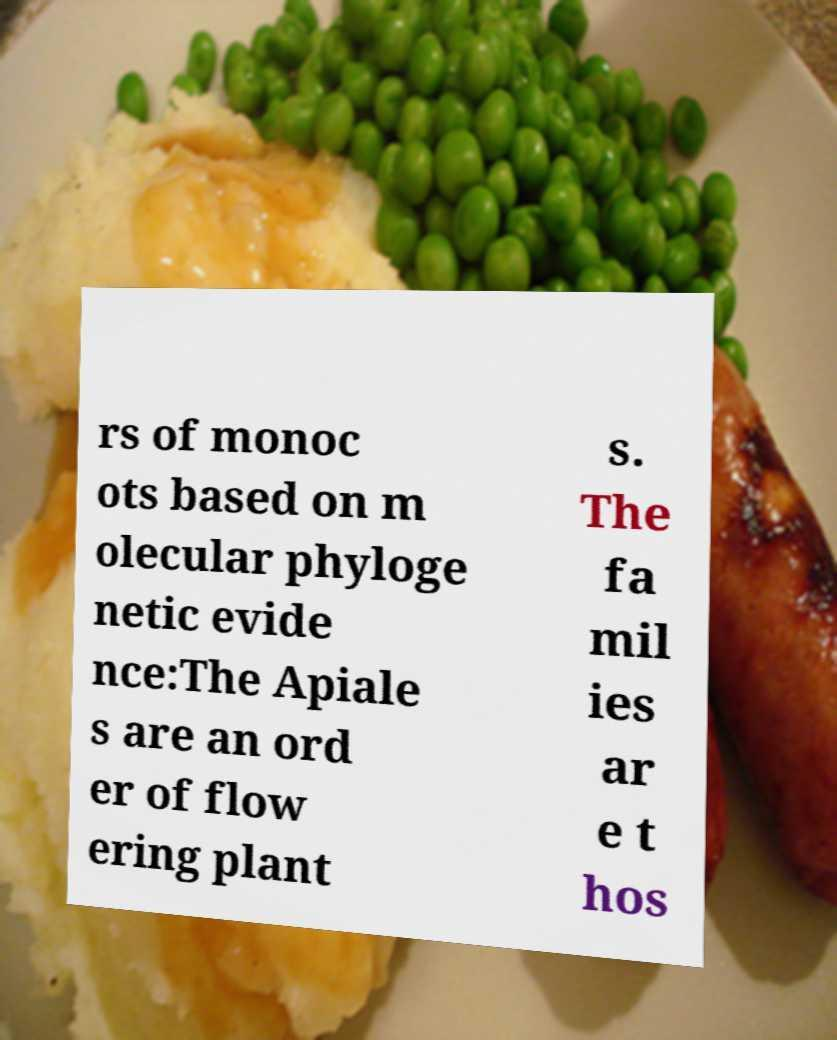Please identify and transcribe the text found in this image. rs of monoc ots based on m olecular phyloge netic evide nce:The Apiale s are an ord er of flow ering plant s. The fa mil ies ar e t hos 